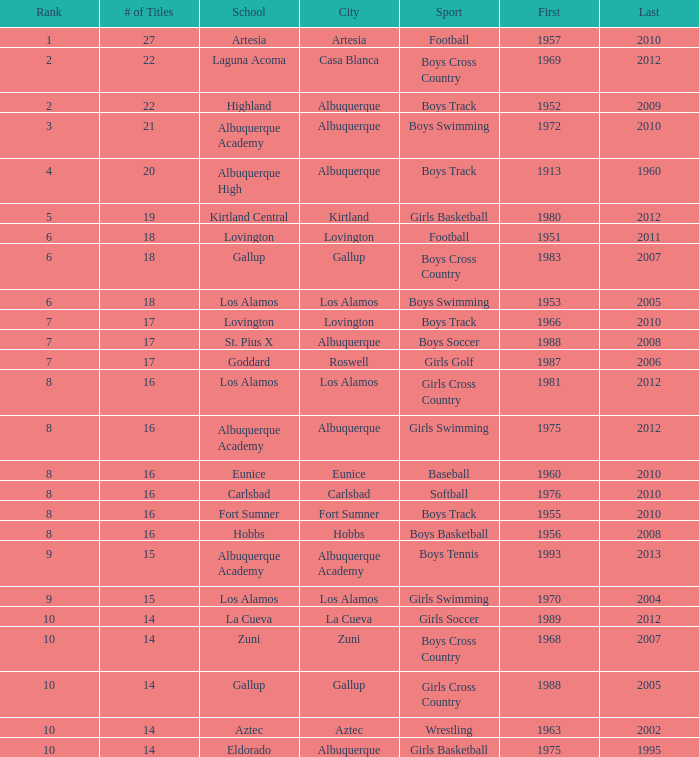What is the highest rank for the boys swimming team in Albuquerque? 3.0. 